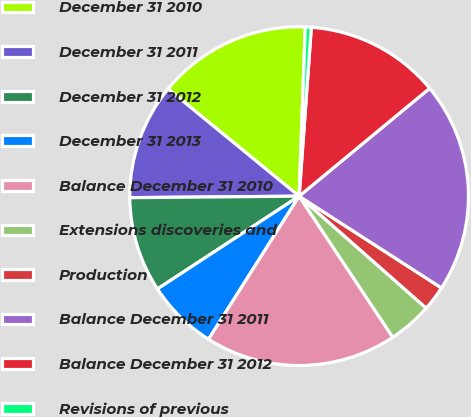<chart> <loc_0><loc_0><loc_500><loc_500><pie_chart><fcel>December 31 2010<fcel>December 31 2011<fcel>December 31 2012<fcel>December 31 2013<fcel>Balance December 31 2010<fcel>Extensions discoveries and<fcel>Production<fcel>Balance December 31 2011<fcel>Balance December 31 2012<fcel>Revisions of previous<nl><fcel>14.66%<fcel>11.06%<fcel>9.09%<fcel>6.79%<fcel>18.31%<fcel>4.18%<fcel>2.38%<fcel>20.11%<fcel>12.86%<fcel>0.57%<nl></chart> 